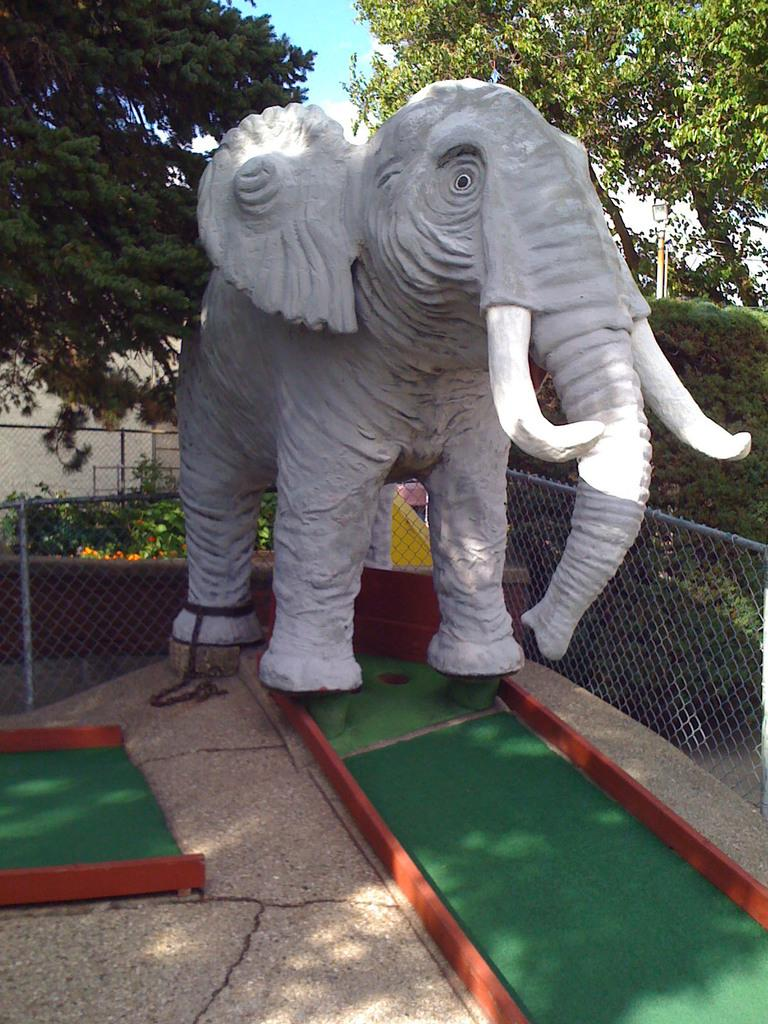What is the main subject of the image? There is a statue of an elephant in the image. What can be seen in the background of the image? There are trees in the image. What type of rake is being used to trim the trees in the image? There is no rake present in the image, and the trees are not being trimmed. 